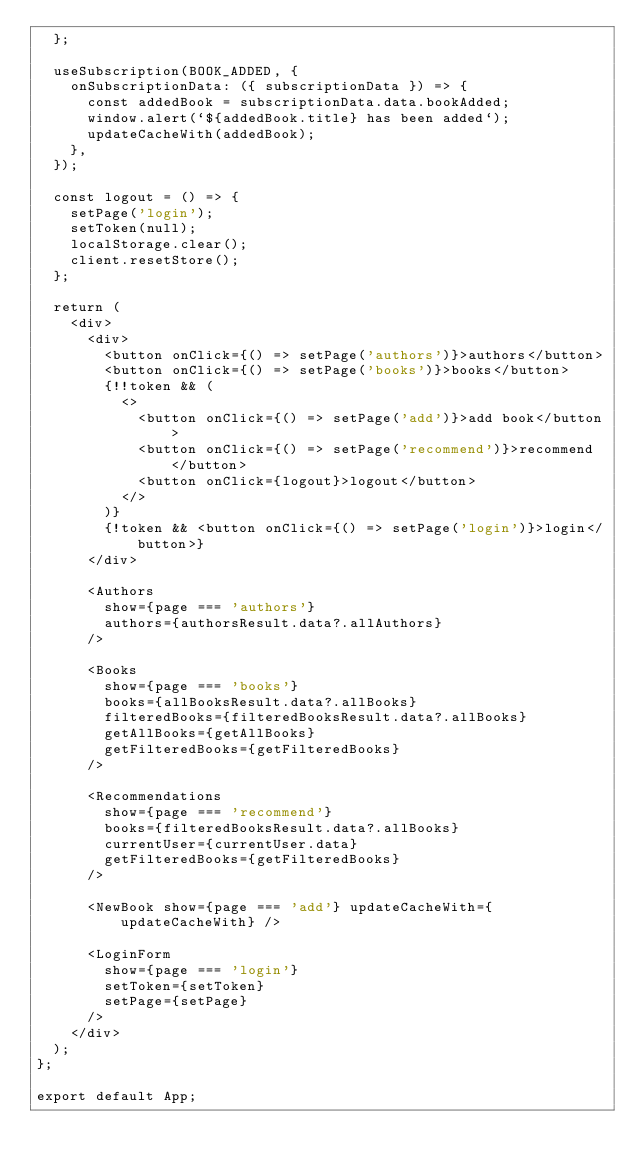Convert code to text. <code><loc_0><loc_0><loc_500><loc_500><_JavaScript_>  };

  useSubscription(BOOK_ADDED, {
    onSubscriptionData: ({ subscriptionData }) => {
      const addedBook = subscriptionData.data.bookAdded;
      window.alert(`${addedBook.title} has been added`);
      updateCacheWith(addedBook);
    },
  });

  const logout = () => {
    setPage('login');
    setToken(null);
    localStorage.clear();
    client.resetStore();
  };

  return (
    <div>
      <div>
        <button onClick={() => setPage('authors')}>authors</button>
        <button onClick={() => setPage('books')}>books</button>
        {!!token && (
          <>
            <button onClick={() => setPage('add')}>add book</button>
            <button onClick={() => setPage('recommend')}>recommend</button>
            <button onClick={logout}>logout</button>
          </>
        )}
        {!token && <button onClick={() => setPage('login')}>login</button>}
      </div>

      <Authors
        show={page === 'authors'}
        authors={authorsResult.data?.allAuthors}
      />

      <Books
        show={page === 'books'}
        books={allBooksResult.data?.allBooks}
        filteredBooks={filteredBooksResult.data?.allBooks}
        getAllBooks={getAllBooks}
        getFilteredBooks={getFilteredBooks}
      />

      <Recommendations
        show={page === 'recommend'}
        books={filteredBooksResult.data?.allBooks}
        currentUser={currentUser.data}
        getFilteredBooks={getFilteredBooks}
      />

      <NewBook show={page === 'add'} updateCacheWith={updateCacheWith} />

      <LoginForm
        show={page === 'login'}
        setToken={setToken}
        setPage={setPage}
      />
    </div>
  );
};

export default App;
</code> 